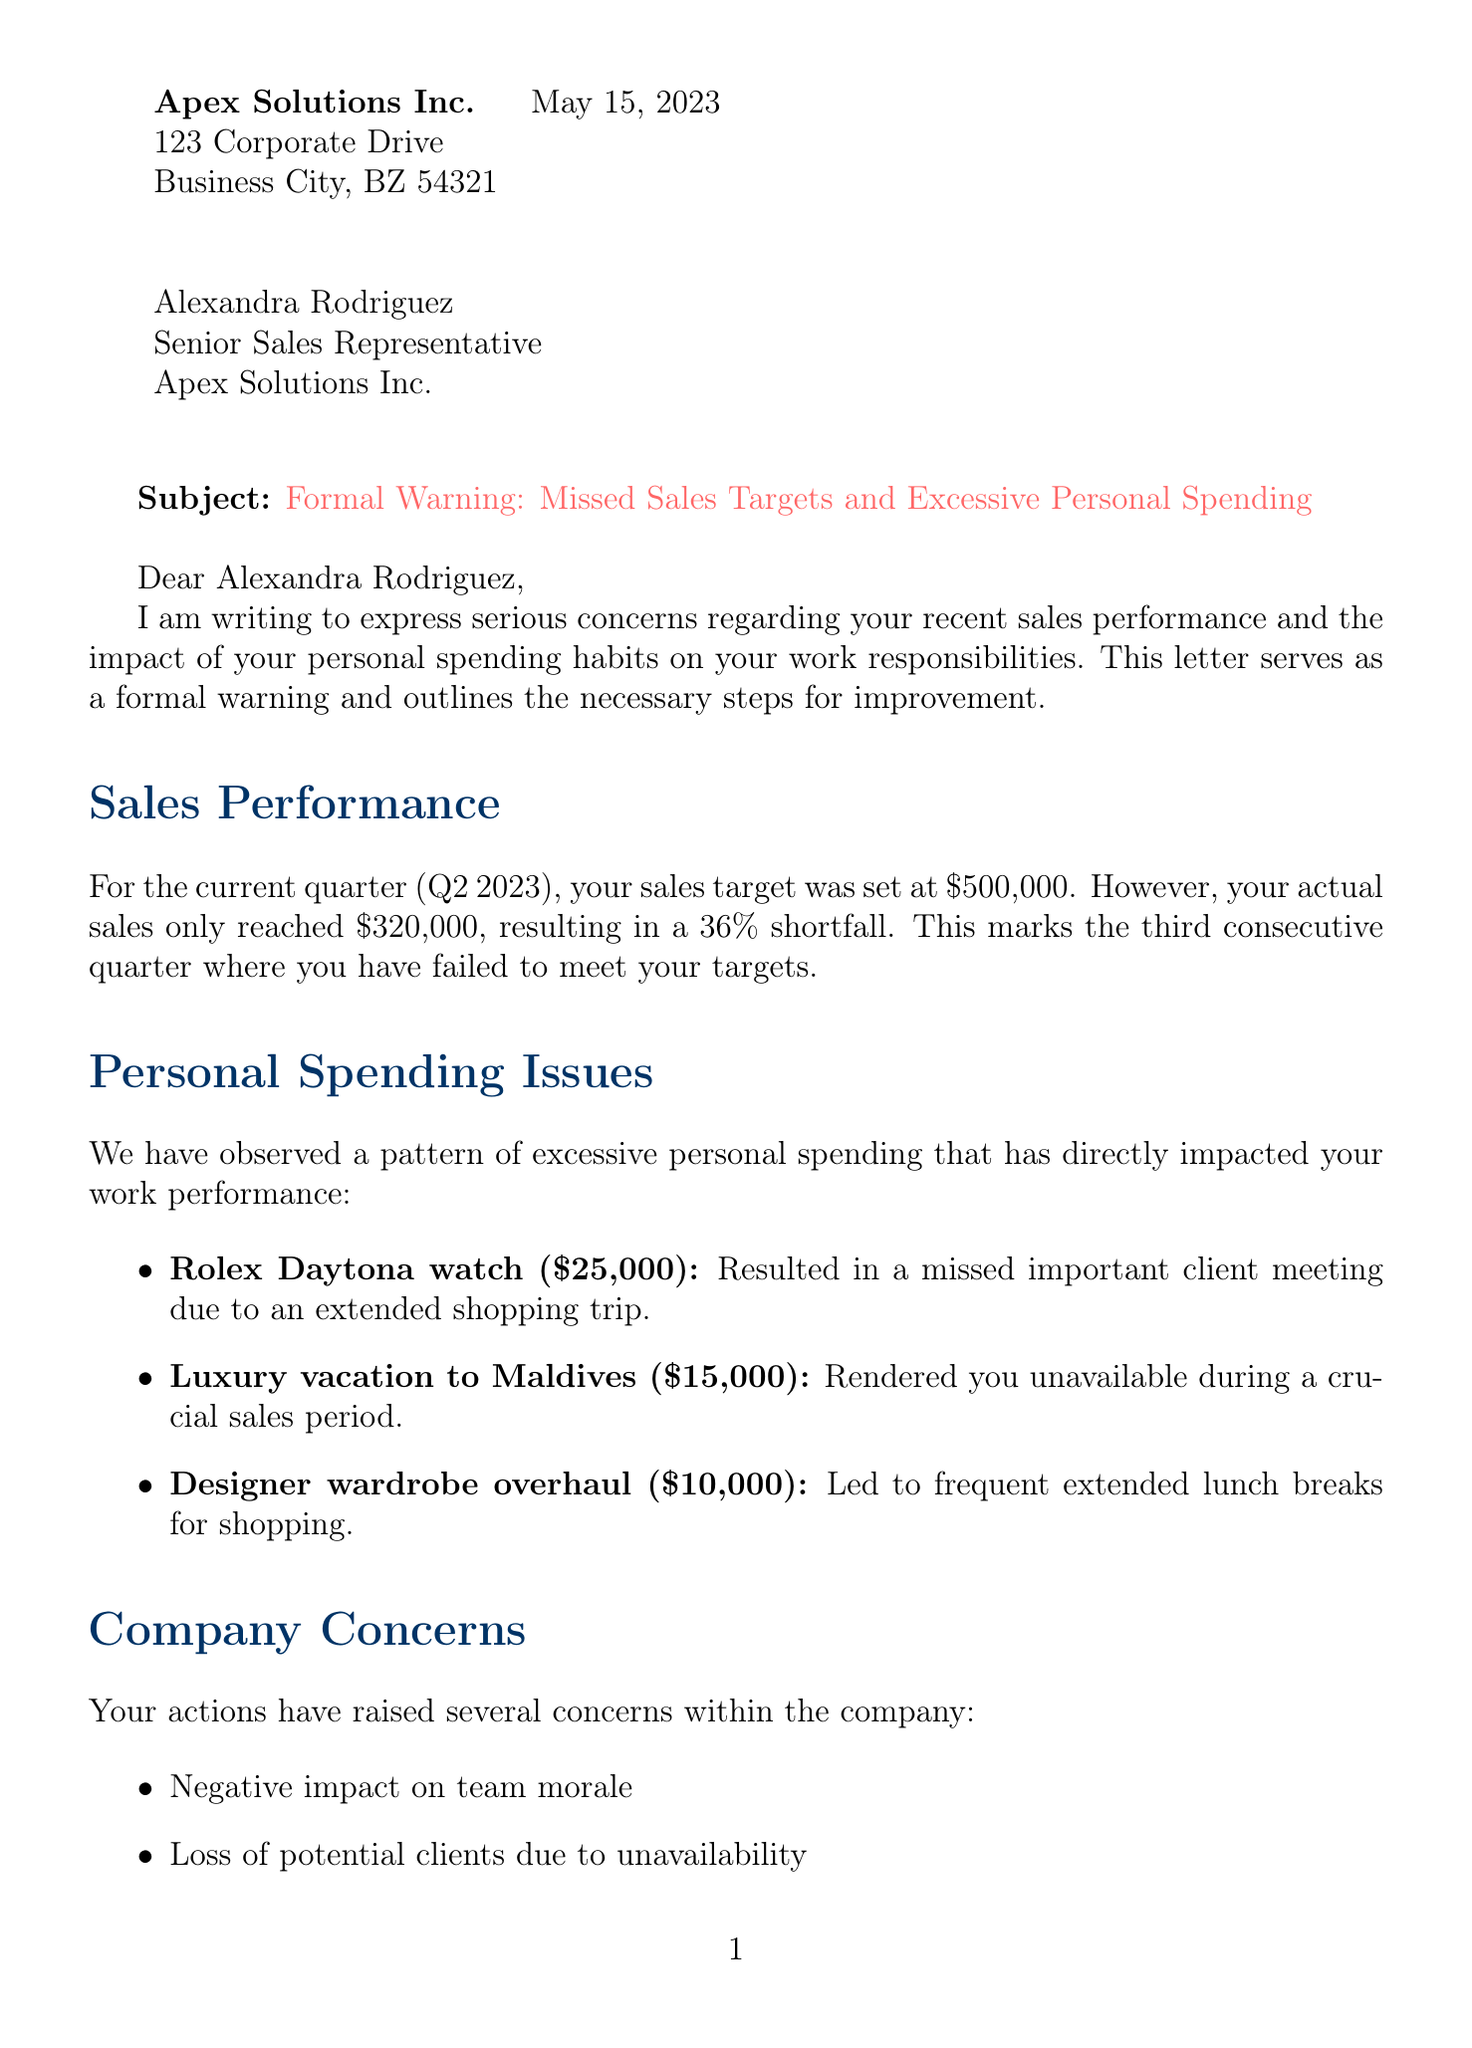What is the name of the sender? The sender is James Whitaker, as stated at the beginning of the letter.
Answer: James Whitaker What is the target sales amount for Q2 2023? The target sales amount is specified clearly as $500,000 in the sales performance section.
Answer: $500,000 How much did Alexandra Rodriguez actually sell in Q2 2023? The document indicates that her actual sales were $320,000, which is detailed in the sales performance section.
Answer: $320,000 What percent of the sales target was missed? The percentage missed is mentioned as 36% in the sales performance section of the letter.
Answer: 36% How many consecutive quarters has Alexandra missed her sales targets? The letter states that this is the third consecutive quarter that she has failed to meet her targets.
Answer: 3 Which luxury item caused Alexandra to miss an important client meeting? The document identifies the Rolex Daytona watch as the item that resulted in a missed important client meeting.
Answer: Rolex Daytona watch What type of seminar is scheduled for June 1, 2023? The document lists a Financial Wellness Seminar on June 1, 2023, indicating its purpose is financial management.
Answer: Financial Wellness Seminar What consequence is mentioned for not improving performance? The letter includes potential demotion or reassignment as a consequence for failing to improve.
Answer: Potential demotion or reassignment What is one suggestion for improvement mentioned in the letter? The document suggests creating a detailed monthly budget as an improvement plan.
Answer: Create a detailed monthly budget 